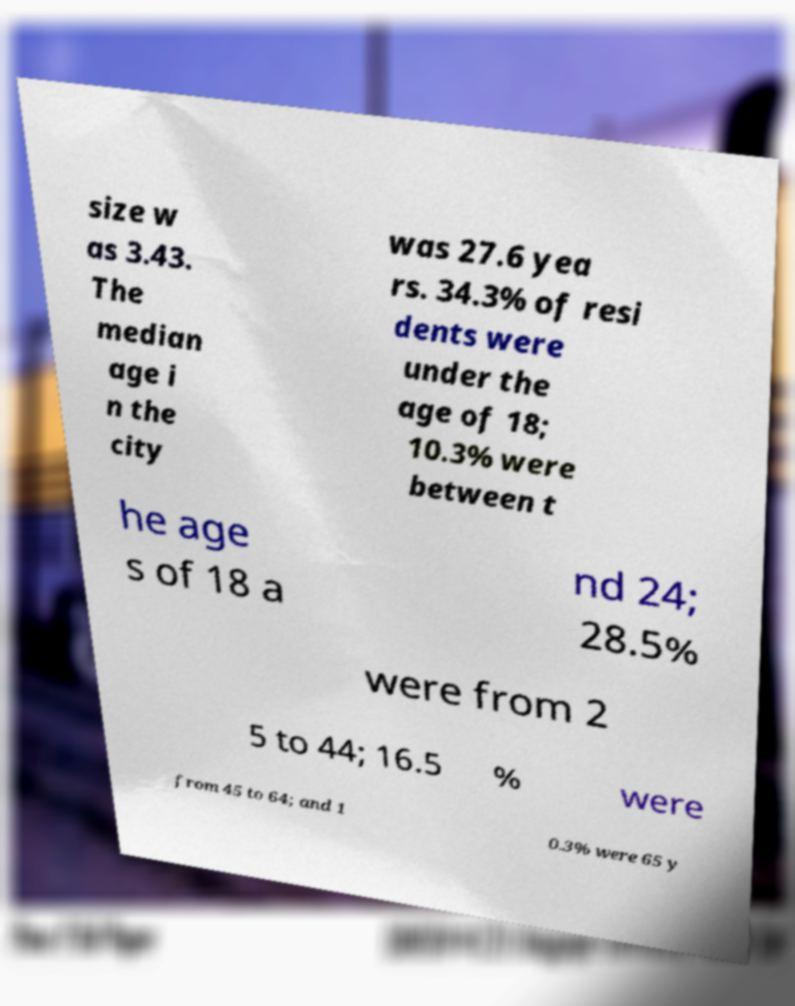Could you assist in decoding the text presented in this image and type it out clearly? size w as 3.43. The median age i n the city was 27.6 yea rs. 34.3% of resi dents were under the age of 18; 10.3% were between t he age s of 18 a nd 24; 28.5% were from 2 5 to 44; 16.5 % were from 45 to 64; and 1 0.3% were 65 y 